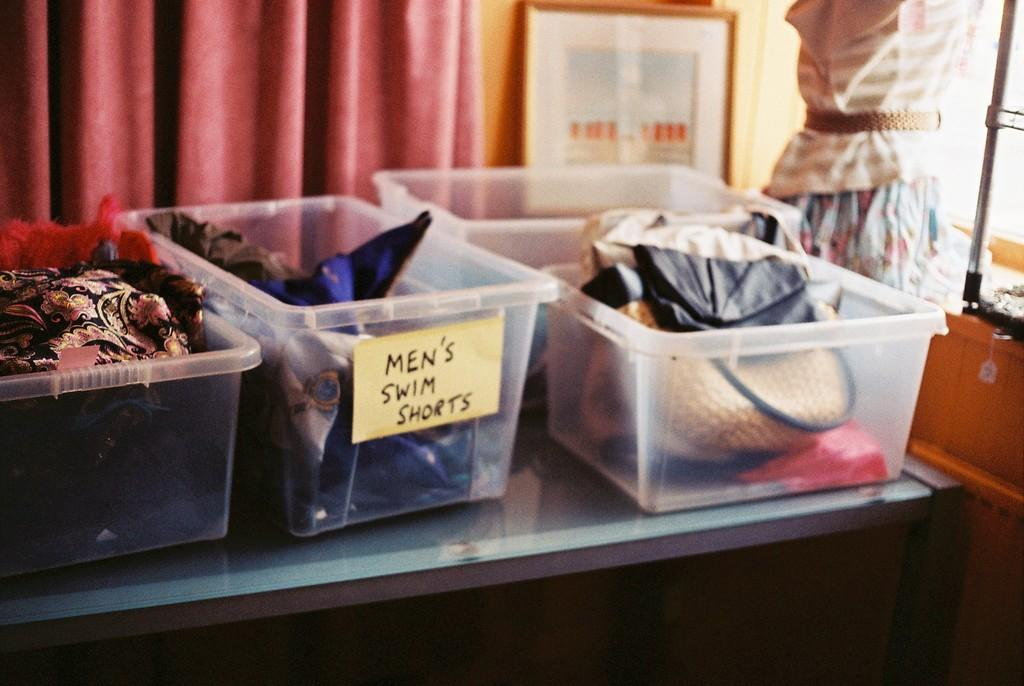<image>
Relay a brief, clear account of the picture shown. Three clear bins on a table top with Mens Swim Short on one bin. 